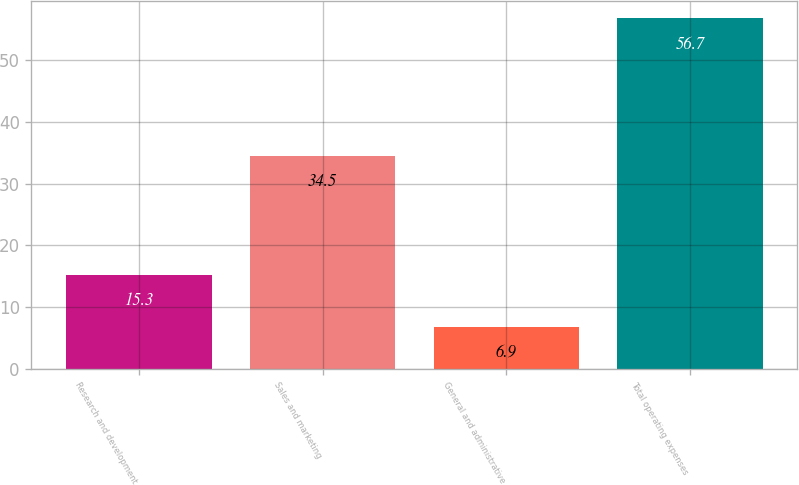Convert chart. <chart><loc_0><loc_0><loc_500><loc_500><bar_chart><fcel>Research and development<fcel>Sales and marketing<fcel>General and administrative<fcel>Total operating expenses<nl><fcel>15.3<fcel>34.5<fcel>6.9<fcel>56.7<nl></chart> 